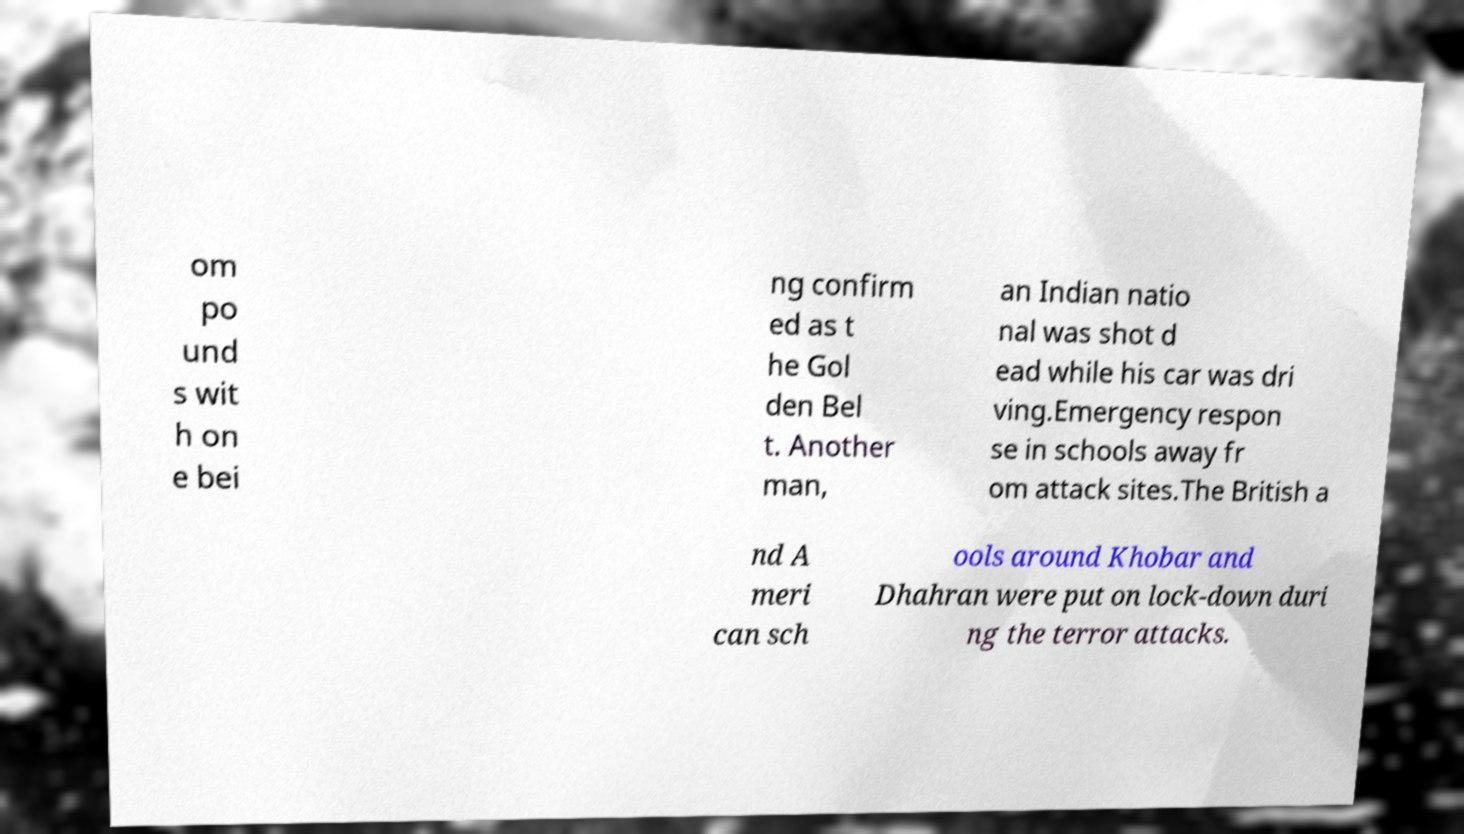What messages or text are displayed in this image? I need them in a readable, typed format. om po und s wit h on e bei ng confirm ed as t he Gol den Bel t. Another man, an Indian natio nal was shot d ead while his car was dri ving.Emergency respon se in schools away fr om attack sites.The British a nd A meri can sch ools around Khobar and Dhahran were put on lock-down duri ng the terror attacks. 